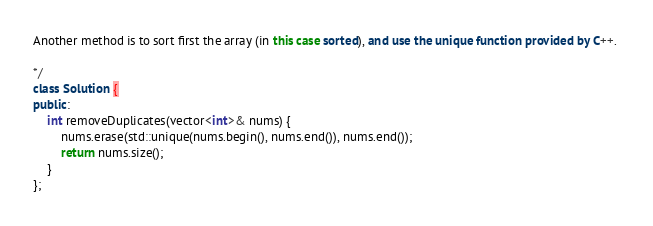<code> <loc_0><loc_0><loc_500><loc_500><_C++_>
Another method is to sort first the array (in this case sorted), and use the unique function provided by C++. 

*/
class Solution {
public:
    int removeDuplicates(vector<int>& nums) {
        nums.erase(std::unique(nums.begin(), nums.end()), nums.end());
        return nums.size();
    }
};</code> 